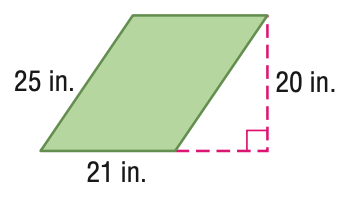Question: Find the area of the parallelogram. Round to the nearest tenth if necessary.
Choices:
A. 92
B. 210
C. 420
D. 525
Answer with the letter. Answer: C Question: Find the perimeter of the parallelogram. Round to the nearest tenth if necessary.
Choices:
A. 46
B. 92
C. 184
D. 420
Answer with the letter. Answer: B 